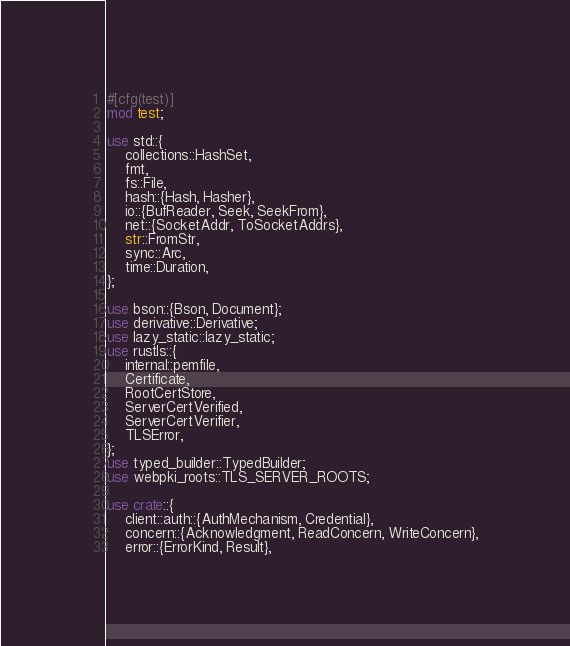Convert code to text. <code><loc_0><loc_0><loc_500><loc_500><_Rust_>#[cfg(test)]
mod test;

use std::{
    collections::HashSet,
    fmt,
    fs::File,
    hash::{Hash, Hasher},
    io::{BufReader, Seek, SeekFrom},
    net::{SocketAddr, ToSocketAddrs},
    str::FromStr,
    sync::Arc,
    time::Duration,
};

use bson::{Bson, Document};
use derivative::Derivative;
use lazy_static::lazy_static;
use rustls::{
    internal::pemfile,
    Certificate,
    RootCertStore,
    ServerCertVerified,
    ServerCertVerifier,
    TLSError,
};
use typed_builder::TypedBuilder;
use webpki_roots::TLS_SERVER_ROOTS;

use crate::{
    client::auth::{AuthMechanism, Credential},
    concern::{Acknowledgment, ReadConcern, WriteConcern},
    error::{ErrorKind, Result},</code> 